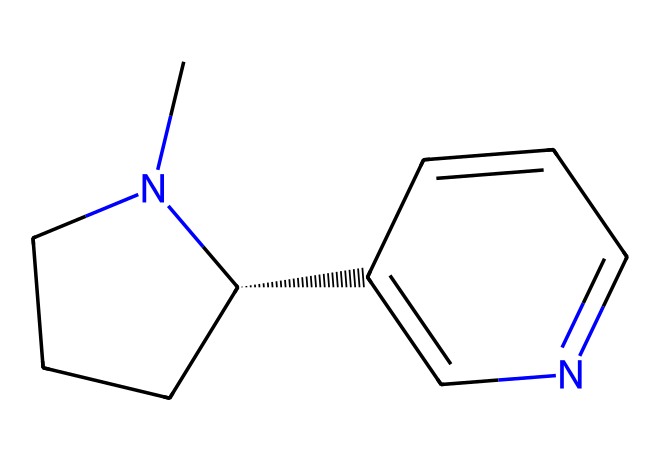how many carbon atoms are present in this structure? By analyzing the SMILES representation, we can identify the carbon atoms. Each 'C' in the SMILES indicates a carbon atom, and we count them. There are a total of 10 carbon atoms in the structure.
Answer: 10 what is the role of nitrogen atoms in this chemical structure? The nitrogen atoms in this structure are part of the pyridine and piperidine rings, which contribute to the basic properties of nicotine as they can accept protons, making nicotine an alkaloid.
Answer: alkaloid what functional groups are present in this compound? Looking at the SMILES, we see that nicotine has an amine functional group (due to the presence of nitrogen atoms) and is classified as a basic compound. These characteristics define its reactivity and interactions.
Answer: amine how many hydrogen atoms are in this chemical formula? To determine the number of hydrogen atoms, we use the general formula for nitrogen-containing organic compounds and consider the tetravalence of carbon. After calculations based on the structure, we find there are 14 hydrogen atoms.
Answer: 14 what type of drug is nicotine classified as? Nicotine is classified as a stimulant due to its effects on the central nervous system, which is derived from its chemical structure that allows it to interact with neurotransmitter systems.
Answer: stimulant what geometric feature is prominent in the structure of nicotine? The structure of nicotine exhibits a cyclic feature, specifically a bicyclic structure composed of both piperidine and pyridine rings, which is characteristic of various alkaloids.
Answer: bicyclic 